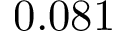<formula> <loc_0><loc_0><loc_500><loc_500>0 . 0 8 1</formula> 